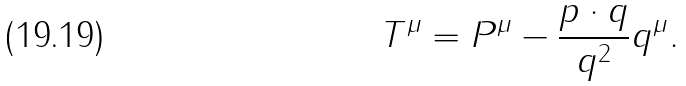<formula> <loc_0><loc_0><loc_500><loc_500>T ^ { \mu } = P ^ { \mu } - \frac { p \cdot q } { q ^ { 2 } } q ^ { \mu } .</formula> 